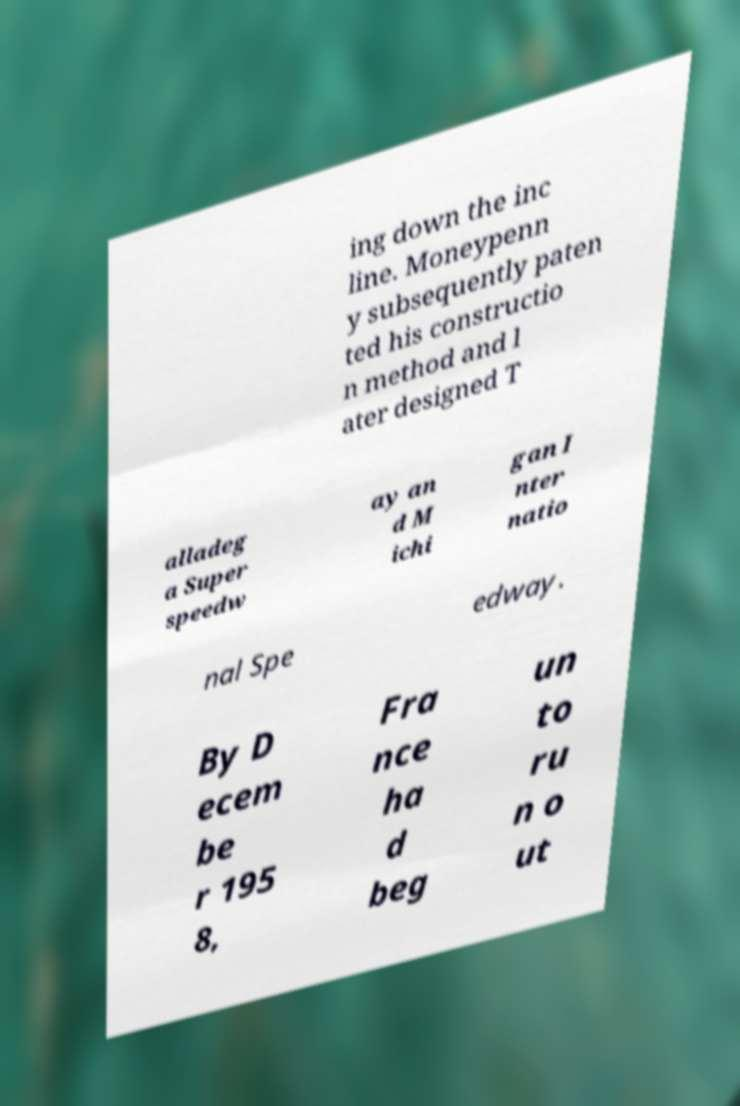For documentation purposes, I need the text within this image transcribed. Could you provide that? ing down the inc line. Moneypenn y subsequently paten ted his constructio n method and l ater designed T alladeg a Super speedw ay an d M ichi gan I nter natio nal Spe edway. By D ecem be r 195 8, Fra nce ha d beg un to ru n o ut 